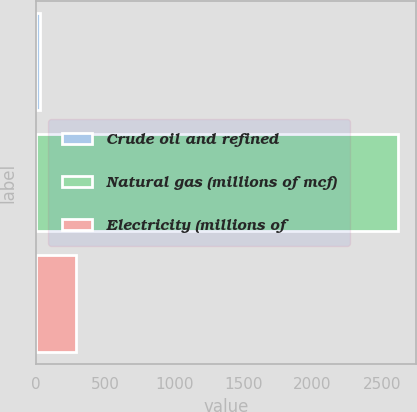Convert chart to OTSL. <chart><loc_0><loc_0><loc_500><loc_500><bar_chart><fcel>Crude oil and refined<fcel>Natural gas (millions of mcf)<fcel>Electricity (millions of<nl><fcel>28<fcel>2616<fcel>286.8<nl></chart> 